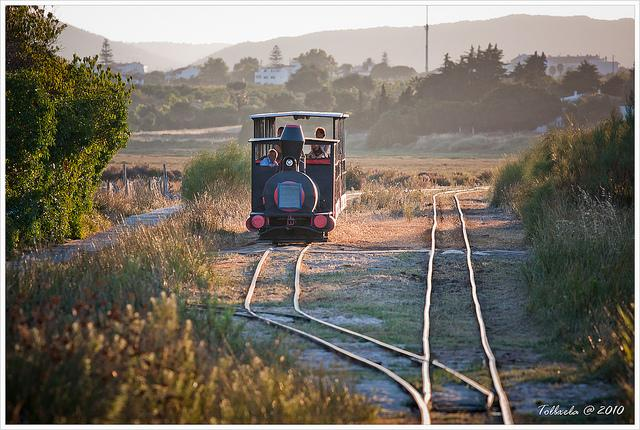How far will this train travel usually?

Choices:
A) 1000 miles
B) local only
C) far away
D) nowhere local only 